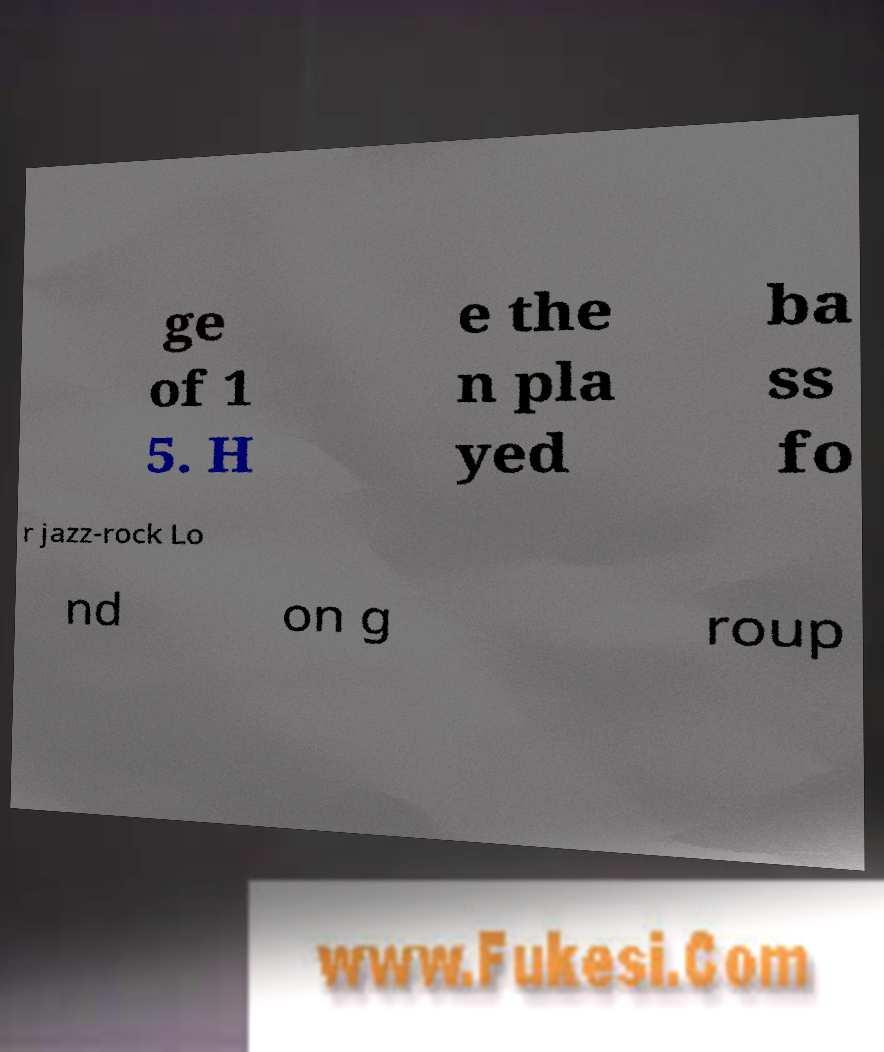Can you read and provide the text displayed in the image?This photo seems to have some interesting text. Can you extract and type it out for me? ge of 1 5. H e the n pla yed ba ss fo r jazz-rock Lo nd on g roup 